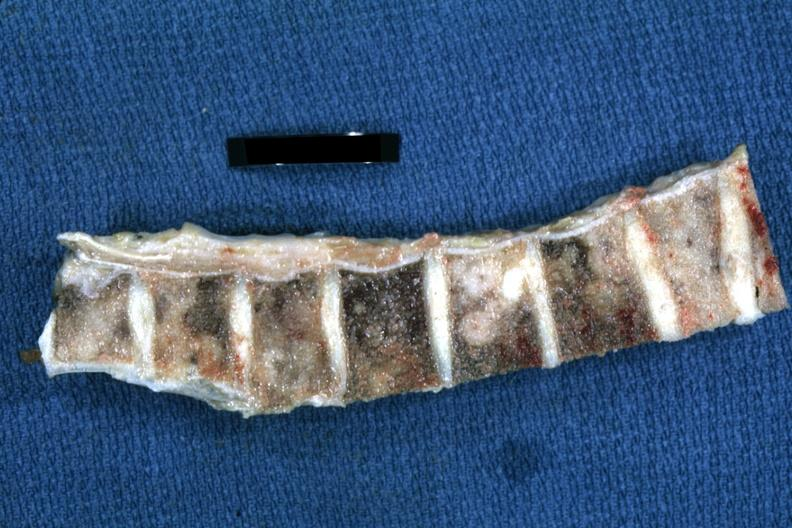does this image show fixed tissue easily seen metastatic lesions breast primary?
Answer the question using a single word or phrase. Yes 